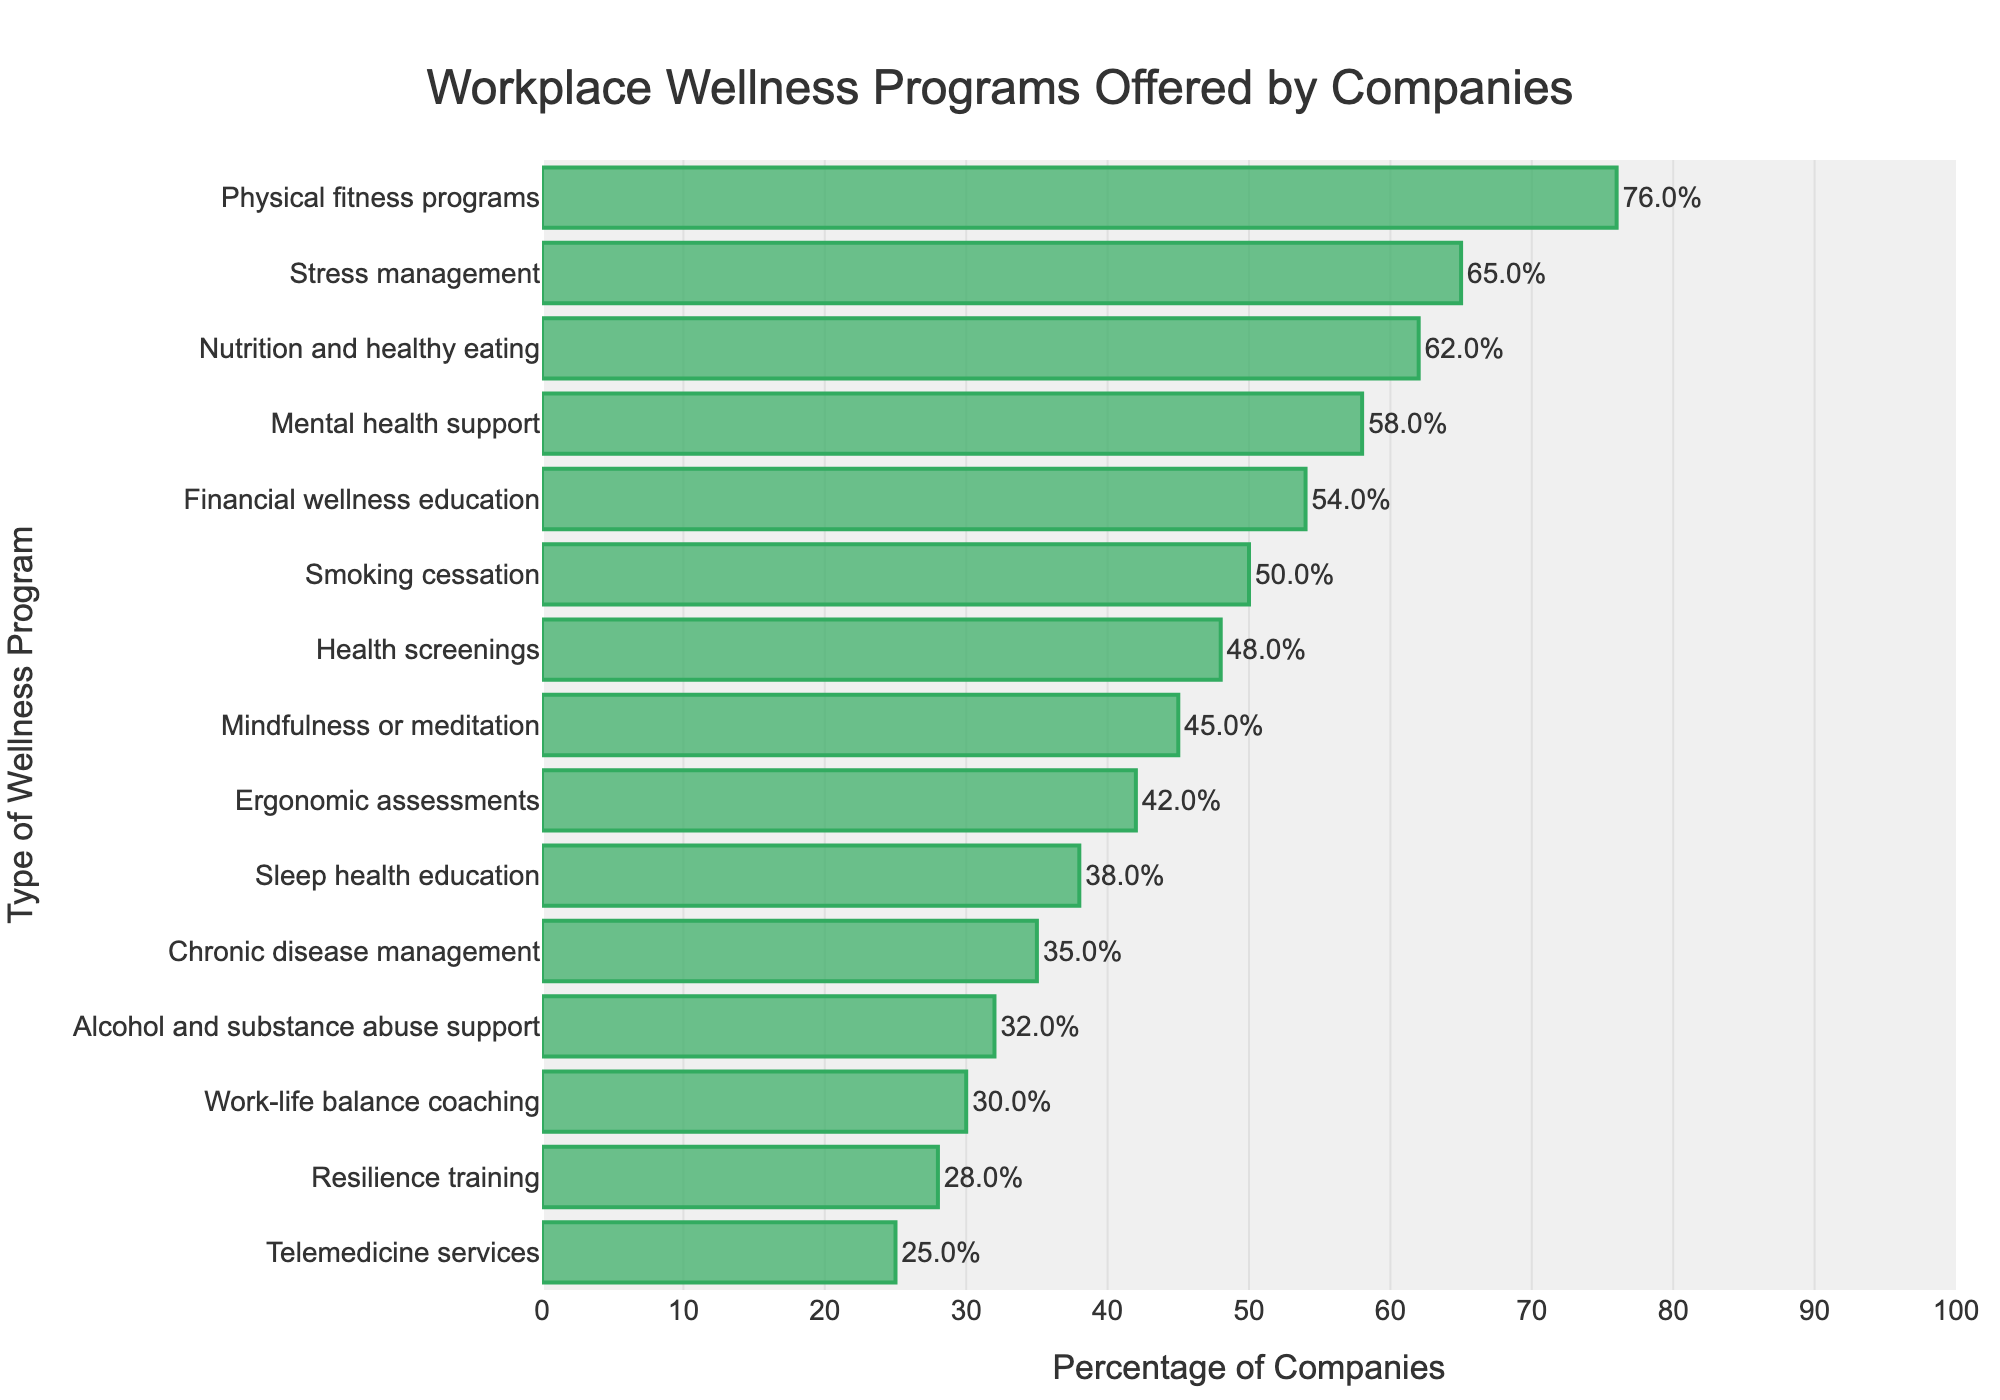What type of wellness program is offered by the highest percentage of companies? By looking at the bar lengths, the longest bar corresponds to "Physical fitness programs" at 76%. This indicates it is the most offered program.
Answer: Physical fitness programs Which wellness program has the lowest percentage of companies offering it? The shortest bar in the chart indicates the program with the lowest percentage, which is "Telemedicine services" at 25%.
Answer: Telemedicine services Which two wellness programs have nearly the same percentage of companies offering them, around 5% difference? The bars for "Chronic disease management" at 35% and "Alcohol and substance abuse support" at 32% are very close, with only a 3% difference.
Answer: Chronic disease management and Alcohol and substance abuse support How many wellness programs are offered by more than 50% of companies? Identify all the bars that extend beyond the 50% mark. The programs are "Physical fitness programs", "Stress management", "Nutrition and healthy eating", "Mental health support", and "Financial wellness education". Count these to get 5 programs.
Answer: 5 Is there a higher percentage of companies offering "Stress management" or "Mindfulness or meditation"? Compare the lengths of the bars. "Stress management" is at 65%, which is higher than "Mindfulness or meditation" at 45%.
Answer: Stress management What is the average percentage of companies offering the "Top 3" programs? Calculate the average of the percentages for "Physical fitness programs" (76%), "Stress management" (65%), and "Nutrition and healthy eating" (62%). Sum these percentages (76 + 65 + 62 = 203), then divide by 3 to get 67.67%.
Answer: 67.67% What is the combined percentage of companies offering "Ergonomic assessments" and "Sleep health education"? Add the percentages for both programs: "Ergonomic assessments" (42%) and "Sleep health education" (38%). 42 + 38 = 80%.
Answer: 80% Which program has a percentage that is half of "Physical fitness programs"? Halve the percentage of "Physical fitness programs" (76/2 = 38%) and identify the program closest to that value, which is "Sleep health education" at 38%.
Answer: Sleep health education Which wellness program related to mental well-being is more popular, "Mental health support" or "Resilience training"? By comparing the bars, "Mental health support" at 58% is higher than "Resilience training" at 28%.
Answer: Mental health support 